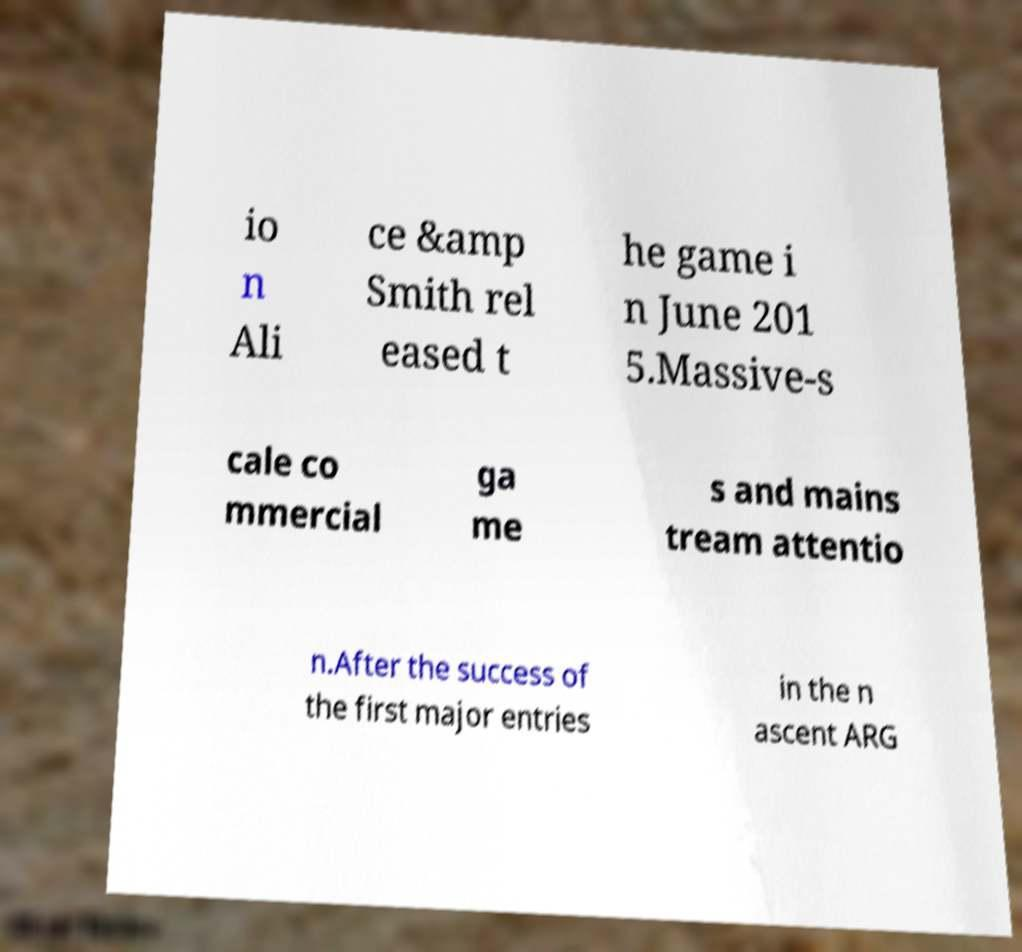There's text embedded in this image that I need extracted. Can you transcribe it verbatim? io n Ali ce &amp Smith rel eased t he game i n June 201 5.Massive-s cale co mmercial ga me s and mains tream attentio n.After the success of the first major entries in the n ascent ARG 